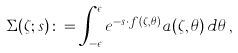<formula> <loc_0><loc_0><loc_500><loc_500>\Sigma ( \zeta ; s ) \colon = \int _ { - \epsilon } ^ { \epsilon } e ^ { - s \cdot f ( \zeta , \theta ) } a ( \zeta , \theta ) \, d \theta \, ,</formula> 